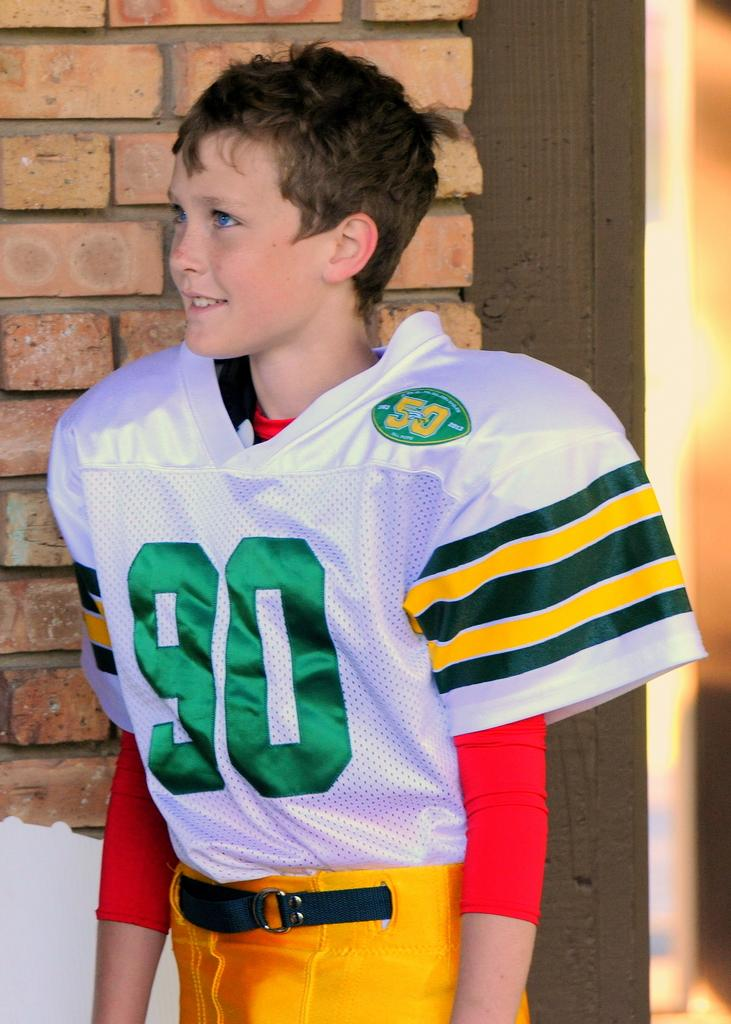Provide a one-sentence caption for the provided image. A young boy in a football jersey wears a green number 90 in full uniform. 